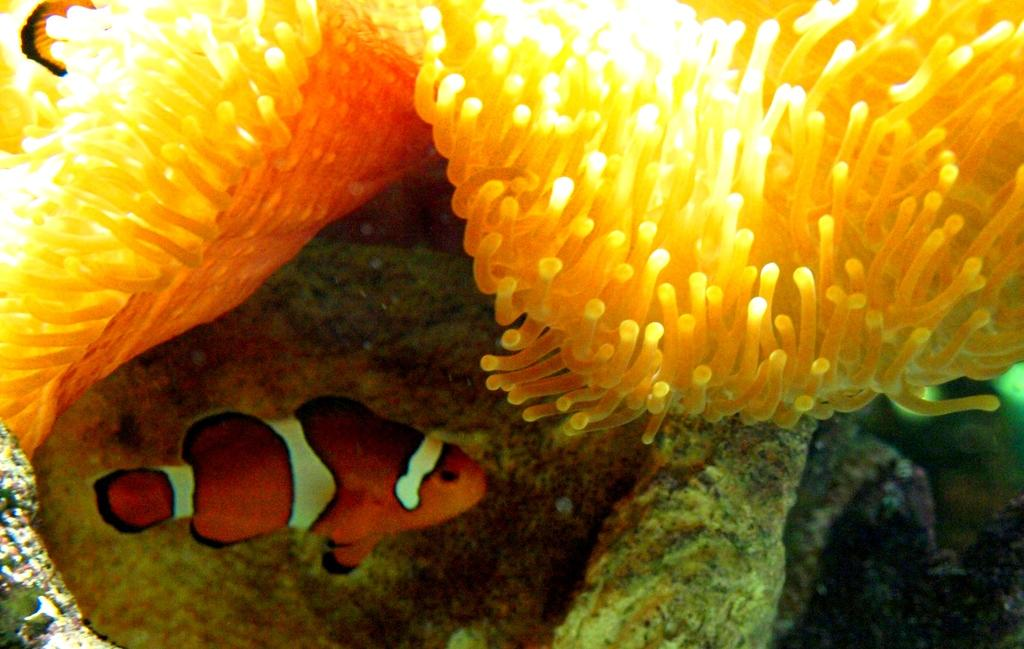What is the focus of the image? The image is a zoomed-in view. What type of creature can be seen in the water body? There is an orange color fish in the water body. What other living organisms are visible in the image? Marine plants are visible at the top of the image. What can be seen in the background of the image? There are some objects in the background of the image. What type of interest rate is being offered by the bank in the image? There is no bank or interest rate mentioned in the image; it features a zoomed-in view of a water body with an orange color fish and marine plants. 